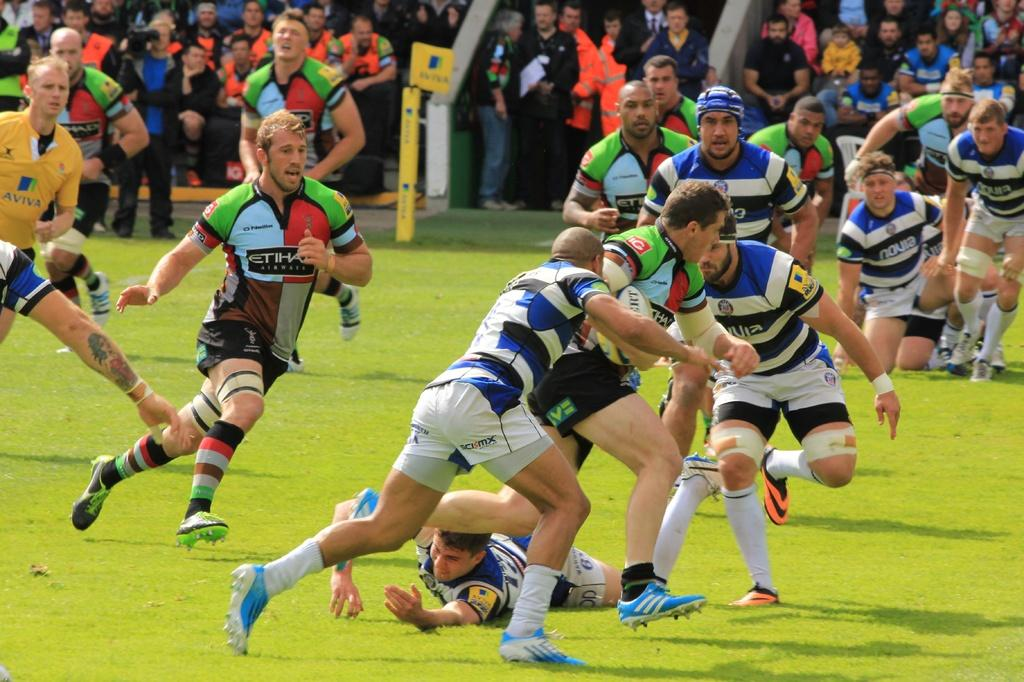<image>
Give a short and clear explanation of the subsequent image. A few yellow Aviva jersey and blue novia jerseys 